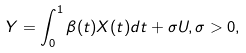Convert formula to latex. <formula><loc_0><loc_0><loc_500><loc_500>Y = \int _ { 0 } ^ { 1 } \beta ( t ) X ( t ) d t + \sigma U , \sigma > 0 ,</formula> 